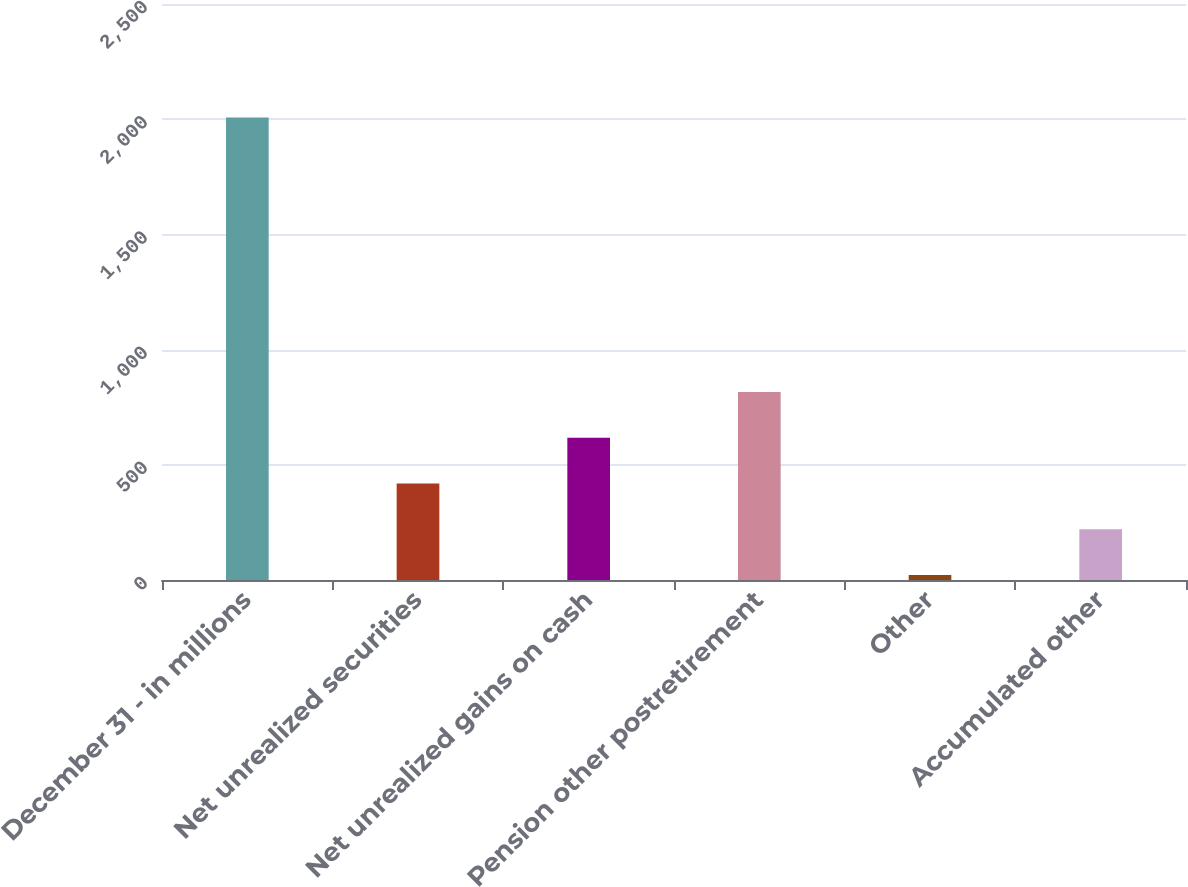Convert chart. <chart><loc_0><loc_0><loc_500><loc_500><bar_chart><fcel>December 31 - in millions<fcel>Net unrealized securities<fcel>Net unrealized gains on cash<fcel>Pension other postretirement<fcel>Other<fcel>Accumulated other<nl><fcel>2007<fcel>419<fcel>617.5<fcel>816<fcel>22<fcel>220.5<nl></chart> 